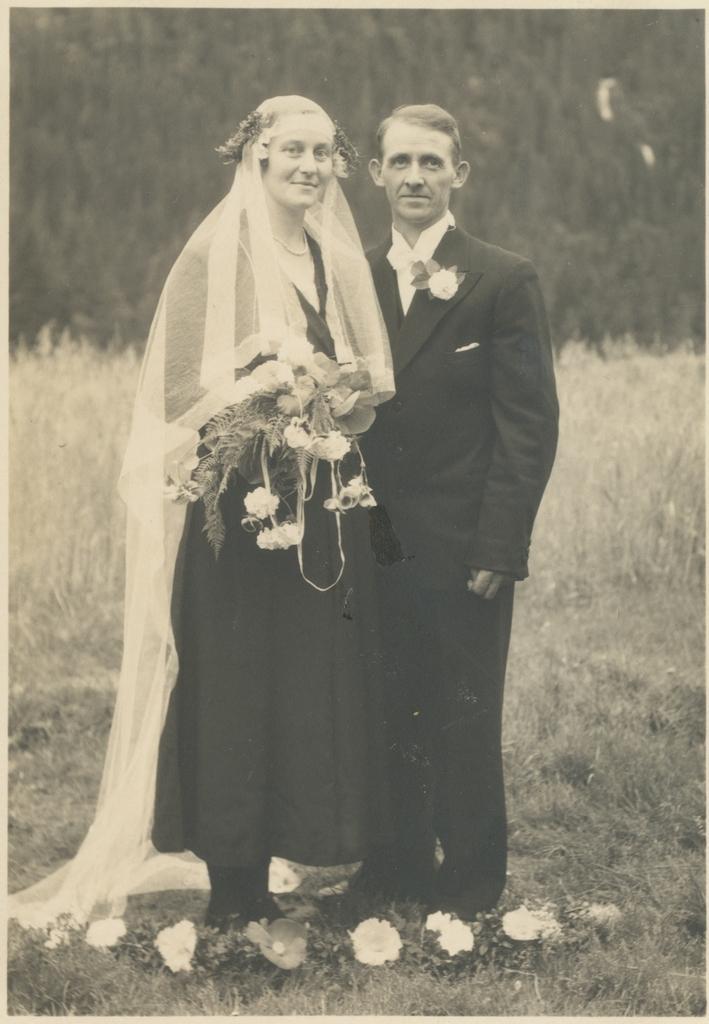Please provide a concise description of this image. This picture shows a man and a woman standing and holding flowers in her hand and we see grass on the ground and we see trees and we see a cloth to the woman's head. 